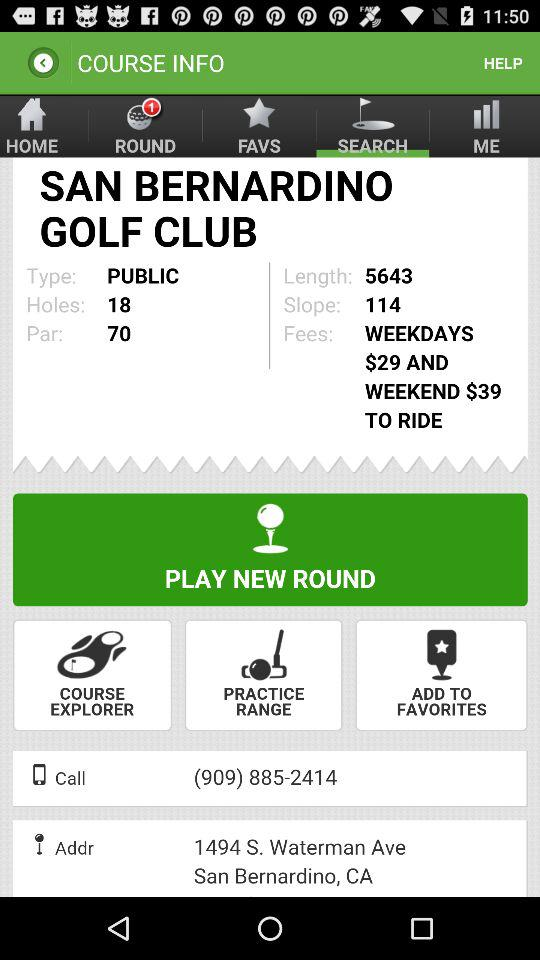How many holes are on this course?
Answer the question using a single word or phrase. 18 